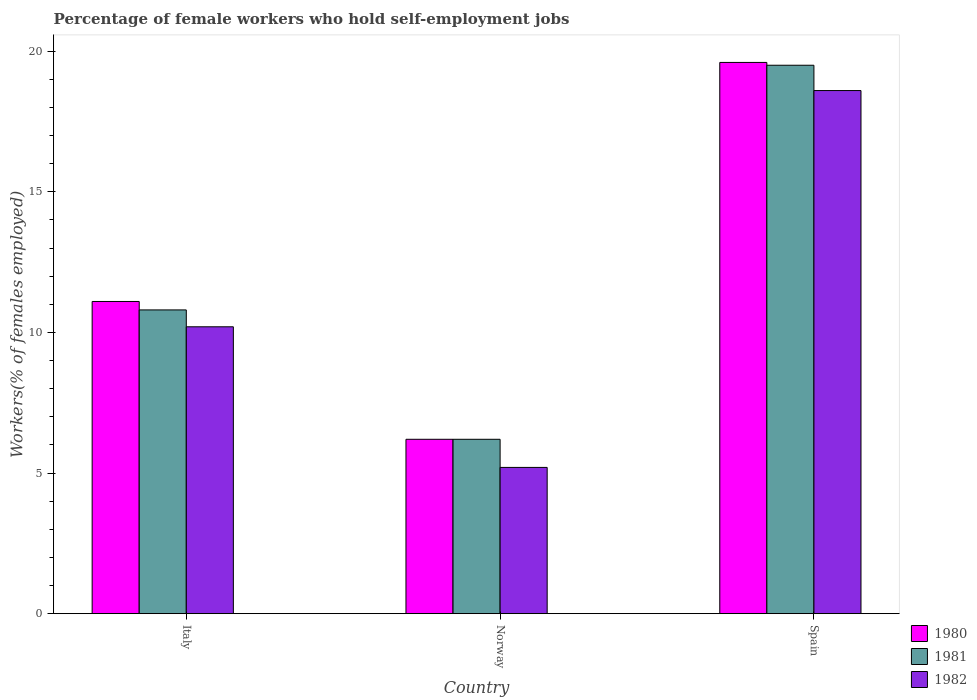How many groups of bars are there?
Ensure brevity in your answer.  3. How many bars are there on the 3rd tick from the right?
Provide a short and direct response. 3. What is the label of the 3rd group of bars from the left?
Your answer should be compact. Spain. What is the percentage of self-employed female workers in 1982 in Spain?
Offer a very short reply. 18.6. Across all countries, what is the maximum percentage of self-employed female workers in 1980?
Offer a terse response. 19.6. Across all countries, what is the minimum percentage of self-employed female workers in 1980?
Your answer should be compact. 6.2. In which country was the percentage of self-employed female workers in 1981 maximum?
Offer a terse response. Spain. What is the total percentage of self-employed female workers in 1982 in the graph?
Provide a succinct answer. 34. What is the difference between the percentage of self-employed female workers in 1981 in Italy and that in Norway?
Your answer should be compact. 4.6. What is the difference between the percentage of self-employed female workers in 1981 in Italy and the percentage of self-employed female workers in 1980 in Norway?
Give a very brief answer. 4.6. What is the average percentage of self-employed female workers in 1982 per country?
Keep it short and to the point. 11.33. In how many countries, is the percentage of self-employed female workers in 1980 greater than 5 %?
Offer a terse response. 3. What is the ratio of the percentage of self-employed female workers in 1982 in Italy to that in Spain?
Offer a terse response. 0.55. Is the percentage of self-employed female workers in 1980 in Italy less than that in Spain?
Your answer should be very brief. Yes. What is the difference between the highest and the second highest percentage of self-employed female workers in 1982?
Provide a succinct answer. 8.4. What is the difference between the highest and the lowest percentage of self-employed female workers in 1980?
Give a very brief answer. 13.4. Is the sum of the percentage of self-employed female workers in 1981 in Norway and Spain greater than the maximum percentage of self-employed female workers in 1980 across all countries?
Your answer should be very brief. Yes. Are all the bars in the graph horizontal?
Offer a very short reply. No. How many countries are there in the graph?
Make the answer very short. 3. Does the graph contain any zero values?
Offer a terse response. No. How many legend labels are there?
Offer a terse response. 3. How are the legend labels stacked?
Provide a short and direct response. Vertical. What is the title of the graph?
Provide a short and direct response. Percentage of female workers who hold self-employment jobs. Does "2013" appear as one of the legend labels in the graph?
Offer a terse response. No. What is the label or title of the Y-axis?
Keep it short and to the point. Workers(% of females employed). What is the Workers(% of females employed) in 1980 in Italy?
Offer a terse response. 11.1. What is the Workers(% of females employed) of 1981 in Italy?
Offer a very short reply. 10.8. What is the Workers(% of females employed) in 1982 in Italy?
Your answer should be compact. 10.2. What is the Workers(% of females employed) in 1980 in Norway?
Provide a short and direct response. 6.2. What is the Workers(% of females employed) of 1981 in Norway?
Keep it short and to the point. 6.2. What is the Workers(% of females employed) of 1982 in Norway?
Make the answer very short. 5.2. What is the Workers(% of females employed) in 1980 in Spain?
Make the answer very short. 19.6. What is the Workers(% of females employed) of 1981 in Spain?
Provide a succinct answer. 19.5. What is the Workers(% of females employed) of 1982 in Spain?
Offer a very short reply. 18.6. Across all countries, what is the maximum Workers(% of females employed) of 1980?
Your response must be concise. 19.6. Across all countries, what is the maximum Workers(% of females employed) in 1982?
Make the answer very short. 18.6. Across all countries, what is the minimum Workers(% of females employed) of 1980?
Offer a very short reply. 6.2. Across all countries, what is the minimum Workers(% of females employed) of 1981?
Your answer should be very brief. 6.2. Across all countries, what is the minimum Workers(% of females employed) in 1982?
Give a very brief answer. 5.2. What is the total Workers(% of females employed) of 1980 in the graph?
Provide a succinct answer. 36.9. What is the total Workers(% of females employed) of 1981 in the graph?
Offer a very short reply. 36.5. What is the difference between the Workers(% of females employed) of 1981 in Italy and that in Norway?
Your answer should be very brief. 4.6. What is the difference between the Workers(% of females employed) of 1982 in Italy and that in Norway?
Provide a short and direct response. 5. What is the difference between the Workers(% of females employed) of 1981 in Italy and that in Spain?
Your answer should be very brief. -8.7. What is the difference between the Workers(% of females employed) of 1980 in Norway and that in Spain?
Give a very brief answer. -13.4. What is the difference between the Workers(% of females employed) of 1982 in Norway and that in Spain?
Provide a succinct answer. -13.4. What is the difference between the Workers(% of females employed) of 1981 in Italy and the Workers(% of females employed) of 1982 in Norway?
Your response must be concise. 5.6. What is the difference between the Workers(% of females employed) in 1981 in Italy and the Workers(% of females employed) in 1982 in Spain?
Give a very brief answer. -7.8. What is the difference between the Workers(% of females employed) of 1980 in Norway and the Workers(% of females employed) of 1982 in Spain?
Keep it short and to the point. -12.4. What is the difference between the Workers(% of females employed) of 1981 in Norway and the Workers(% of females employed) of 1982 in Spain?
Your answer should be very brief. -12.4. What is the average Workers(% of females employed) of 1980 per country?
Ensure brevity in your answer.  12.3. What is the average Workers(% of females employed) of 1981 per country?
Provide a short and direct response. 12.17. What is the average Workers(% of females employed) of 1982 per country?
Provide a short and direct response. 11.33. What is the difference between the Workers(% of females employed) of 1980 and Workers(% of females employed) of 1981 in Italy?
Your answer should be very brief. 0.3. What is the difference between the Workers(% of females employed) of 1981 and Workers(% of females employed) of 1982 in Italy?
Ensure brevity in your answer.  0.6. What is the difference between the Workers(% of females employed) of 1980 and Workers(% of females employed) of 1981 in Norway?
Make the answer very short. 0. What is the difference between the Workers(% of females employed) in 1980 and Workers(% of females employed) in 1982 in Norway?
Make the answer very short. 1. What is the difference between the Workers(% of females employed) in 1981 and Workers(% of females employed) in 1982 in Norway?
Your answer should be very brief. 1. What is the difference between the Workers(% of females employed) of 1980 and Workers(% of females employed) of 1981 in Spain?
Your response must be concise. 0.1. What is the difference between the Workers(% of females employed) of 1980 and Workers(% of females employed) of 1982 in Spain?
Your response must be concise. 1. What is the difference between the Workers(% of females employed) of 1981 and Workers(% of females employed) of 1982 in Spain?
Make the answer very short. 0.9. What is the ratio of the Workers(% of females employed) in 1980 in Italy to that in Norway?
Your answer should be compact. 1.79. What is the ratio of the Workers(% of females employed) of 1981 in Italy to that in Norway?
Keep it short and to the point. 1.74. What is the ratio of the Workers(% of females employed) of 1982 in Italy to that in Norway?
Offer a terse response. 1.96. What is the ratio of the Workers(% of females employed) of 1980 in Italy to that in Spain?
Your answer should be compact. 0.57. What is the ratio of the Workers(% of females employed) in 1981 in Italy to that in Spain?
Offer a terse response. 0.55. What is the ratio of the Workers(% of females employed) in 1982 in Italy to that in Spain?
Keep it short and to the point. 0.55. What is the ratio of the Workers(% of females employed) in 1980 in Norway to that in Spain?
Provide a short and direct response. 0.32. What is the ratio of the Workers(% of females employed) in 1981 in Norway to that in Spain?
Offer a terse response. 0.32. What is the ratio of the Workers(% of females employed) in 1982 in Norway to that in Spain?
Offer a terse response. 0.28. What is the difference between the highest and the second highest Workers(% of females employed) of 1980?
Offer a terse response. 8.5. What is the difference between the highest and the second highest Workers(% of females employed) of 1981?
Give a very brief answer. 8.7. What is the difference between the highest and the second highest Workers(% of females employed) in 1982?
Provide a succinct answer. 8.4. What is the difference between the highest and the lowest Workers(% of females employed) of 1980?
Make the answer very short. 13.4. What is the difference between the highest and the lowest Workers(% of females employed) of 1981?
Your answer should be very brief. 13.3. What is the difference between the highest and the lowest Workers(% of females employed) in 1982?
Provide a short and direct response. 13.4. 